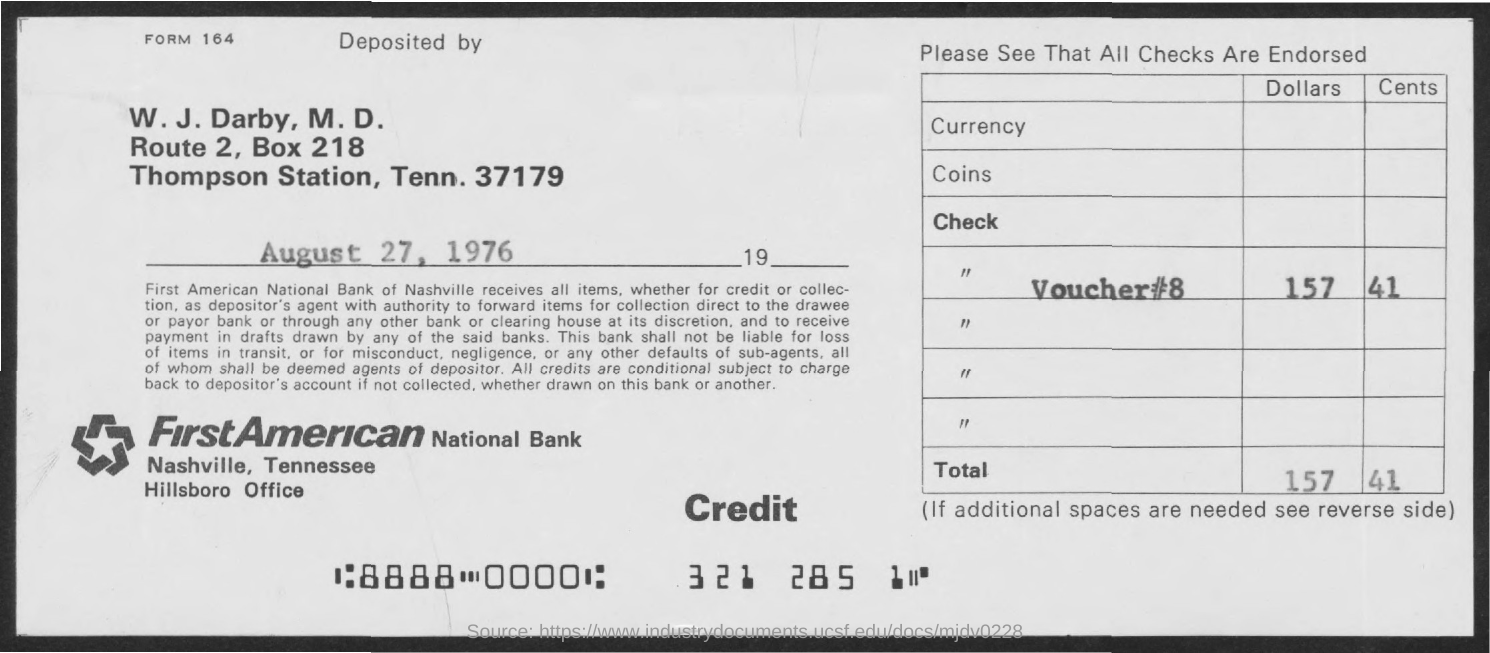What is the BOX Number ?
Your answer should be very brief. 218. What is the Voucher Number ?
Provide a short and direct response. 8. When is the memorandum dated on ?
Offer a terse response. August 27, 1976. 